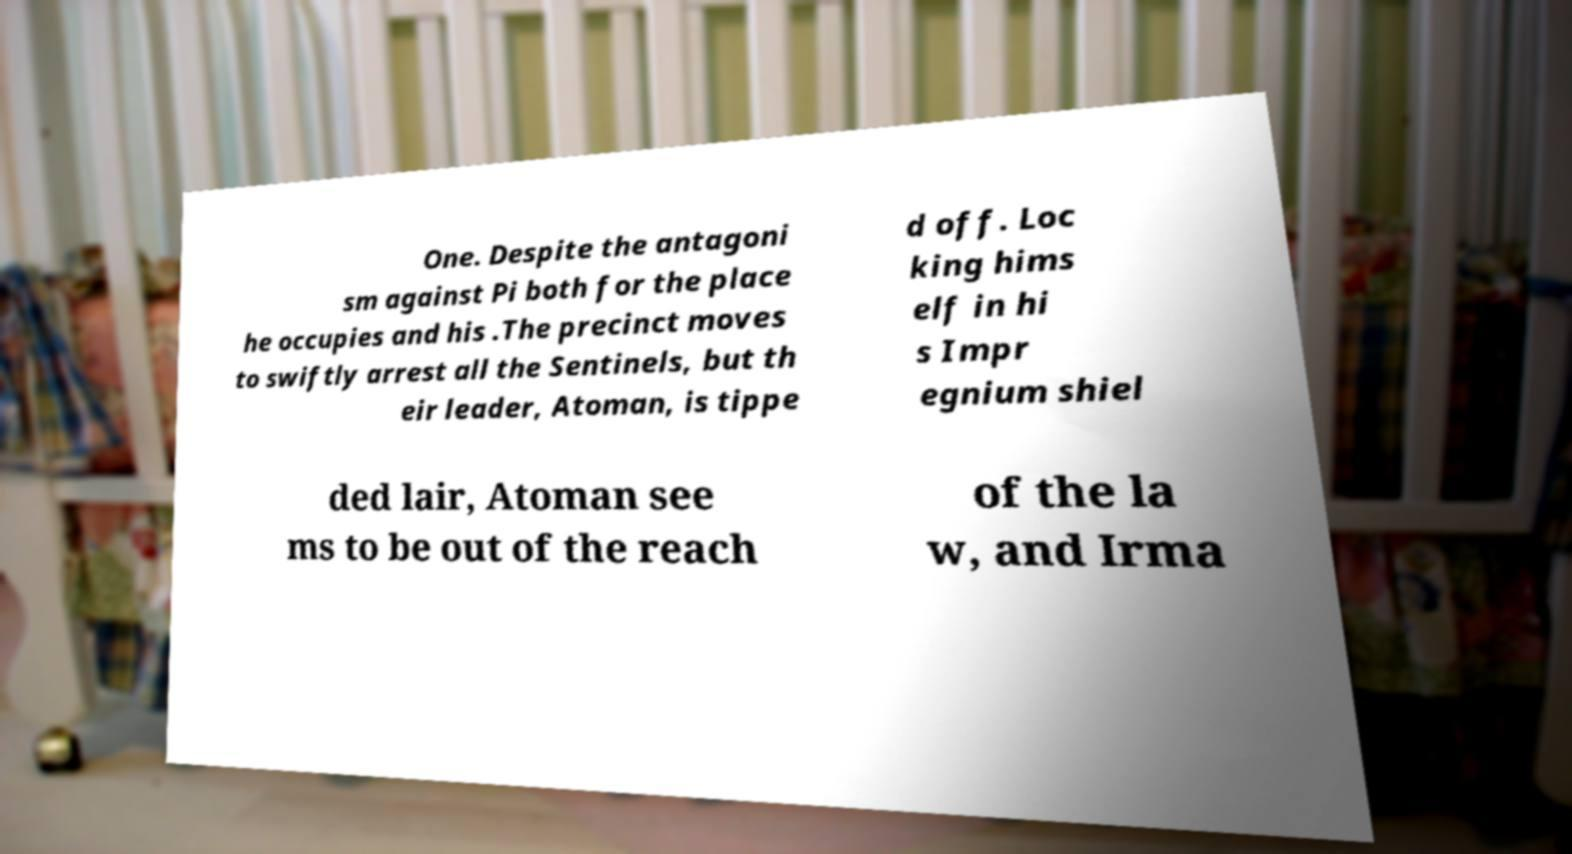Could you assist in decoding the text presented in this image and type it out clearly? One. Despite the antagoni sm against Pi both for the place he occupies and his .The precinct moves to swiftly arrest all the Sentinels, but th eir leader, Atoman, is tippe d off. Loc king hims elf in hi s Impr egnium shiel ded lair, Atoman see ms to be out of the reach of the la w, and Irma 